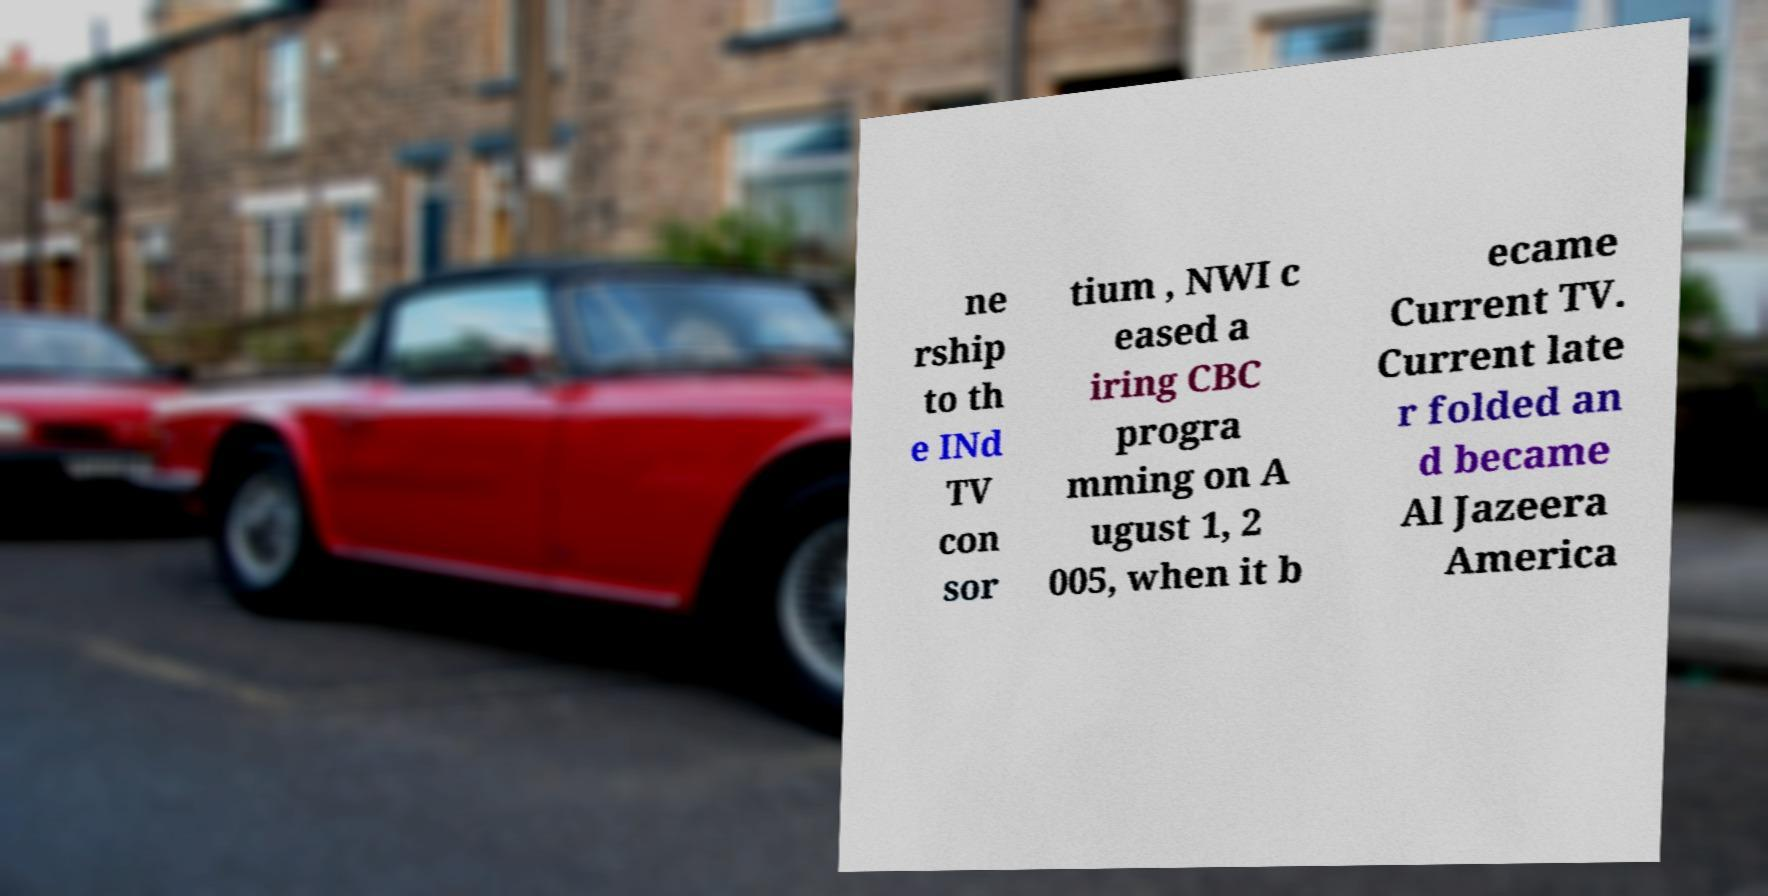Could you extract and type out the text from this image? ne rship to th e INd TV con sor tium , NWI c eased a iring CBC progra mming on A ugust 1, 2 005, when it b ecame Current TV. Current late r folded an d became Al Jazeera America 